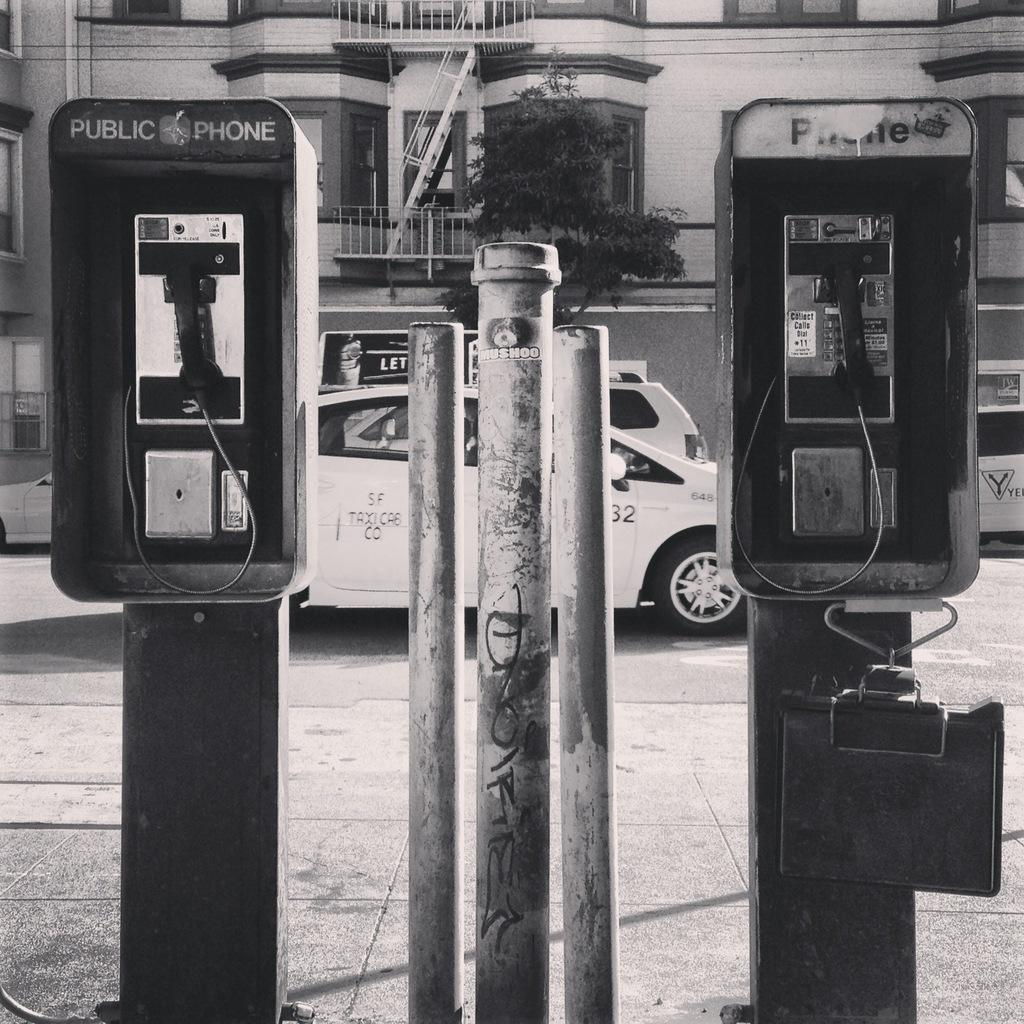<image>
Provide a brief description of the given image. Two public phone booths are on a street with a white car in the background. 